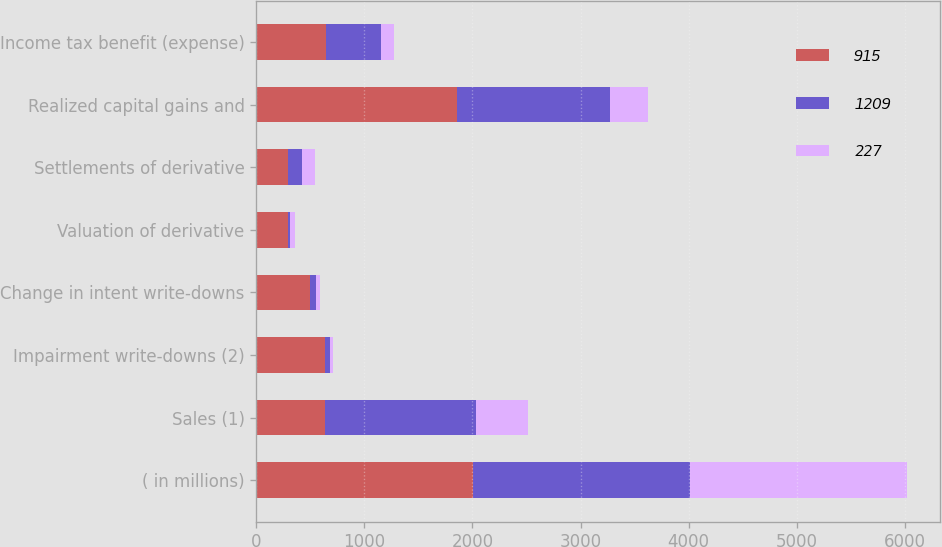Convert chart to OTSL. <chart><loc_0><loc_0><loc_500><loc_500><stacked_bar_chart><ecel><fcel>( in millions)<fcel>Sales (1)<fcel>Impairment write-downs (2)<fcel>Change in intent write-downs<fcel>Valuation of derivative<fcel>Settlements of derivative<fcel>Realized capital gains and<fcel>Income tax benefit (expense)<nl><fcel>915<fcel>2008<fcel>635<fcel>638<fcel>501<fcel>296<fcel>289<fcel>1858<fcel>649<nl><fcel>1209<fcel>2007<fcel>1396<fcel>44<fcel>54<fcel>15<fcel>133<fcel>1416<fcel>501<nl><fcel>227<fcel>2006<fcel>483<fcel>26<fcel>32<fcel>43<fcel>120<fcel>348<fcel>121<nl></chart> 